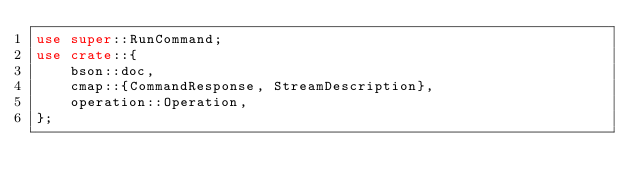Convert code to text. <code><loc_0><loc_0><loc_500><loc_500><_Rust_>use super::RunCommand;
use crate::{
    bson::doc,
    cmap::{CommandResponse, StreamDescription},
    operation::Operation,
};
</code> 